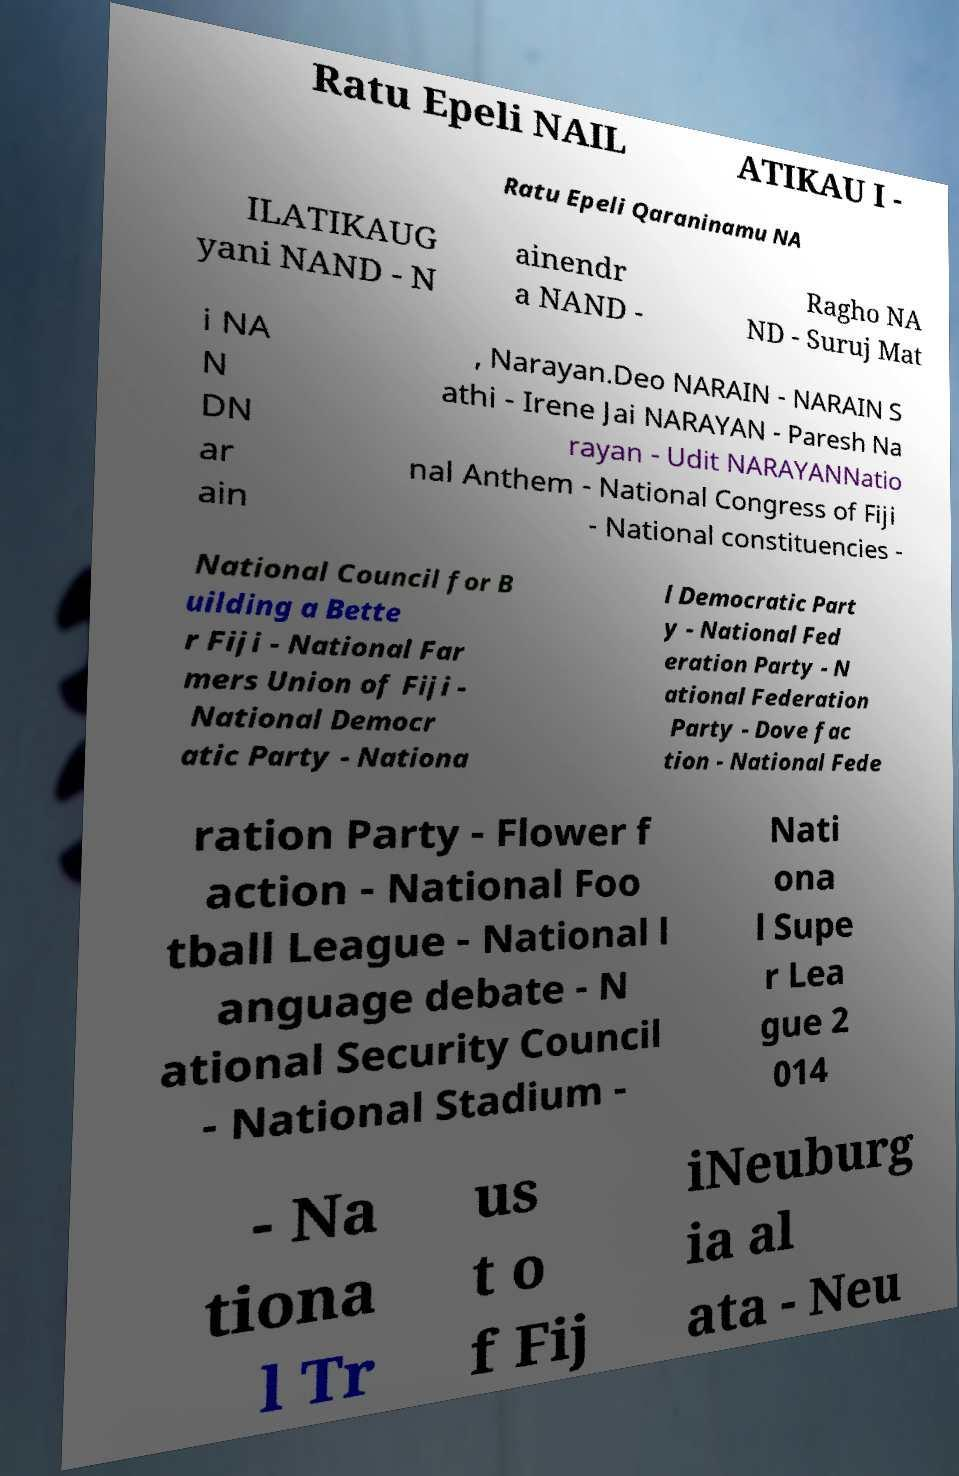Could you assist in decoding the text presented in this image and type it out clearly? Ratu Epeli NAIL ATIKAU I - Ratu Epeli Qaraninamu NA ILATIKAUG yani NAND - N ainendr a NAND - Ragho NA ND - Suruj Mat i NA N DN ar ain , Narayan.Deo NARAIN - NARAIN S athi - Irene Jai NARAYAN - Paresh Na rayan - Udit NARAYANNatio nal Anthem - National Congress of Fiji - National constituencies - National Council for B uilding a Bette r Fiji - National Far mers Union of Fiji - National Democr atic Party - Nationa l Democratic Part y - National Fed eration Party - N ational Federation Party - Dove fac tion - National Fede ration Party - Flower f action - National Foo tball League - National l anguage debate - N ational Security Council - National Stadium - Nati ona l Supe r Lea gue 2 014 - Na tiona l Tr us t o f Fij iNeuburg ia al ata - Neu 